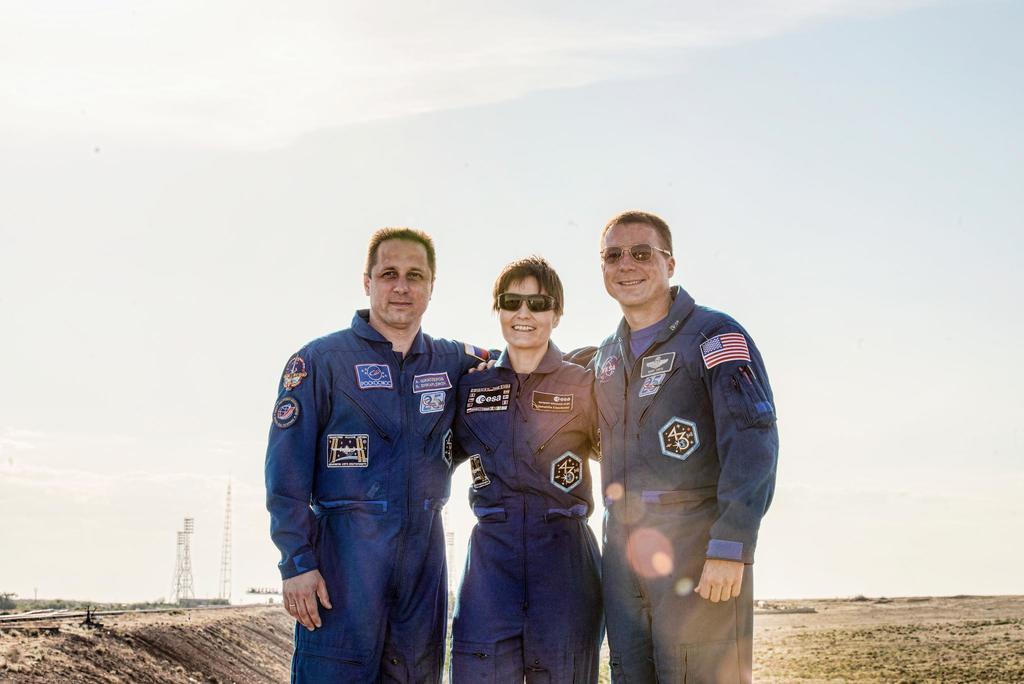How would you summarize this image in a sentence or two? Here I can see three people wearing blue color dresses, standing, smiling and giving pose for the picture. In the background, I can see the ground and two poles. At the top of the image I can see the sky. 